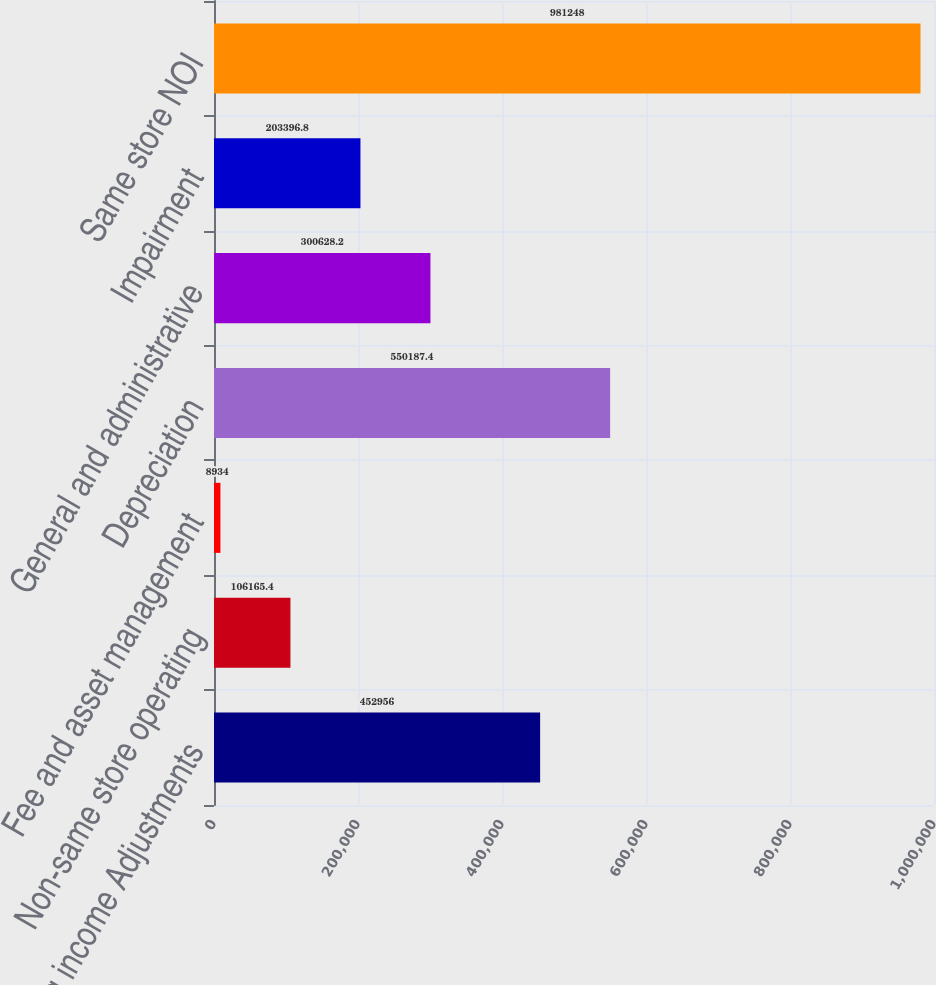Convert chart. <chart><loc_0><loc_0><loc_500><loc_500><bar_chart><fcel>Operating income Adjustments<fcel>Non-same store operating<fcel>Fee and asset management<fcel>Depreciation<fcel>General and administrative<fcel>Impairment<fcel>Same store NOI<nl><fcel>452956<fcel>106165<fcel>8934<fcel>550187<fcel>300628<fcel>203397<fcel>981248<nl></chart> 